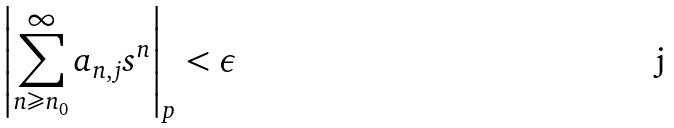<formula> <loc_0><loc_0><loc_500><loc_500>\left | \sum _ { n \geqslant n _ { 0 } } ^ { \infty } a _ { n , j } s ^ { n } \right | _ { p } < \epsilon</formula> 